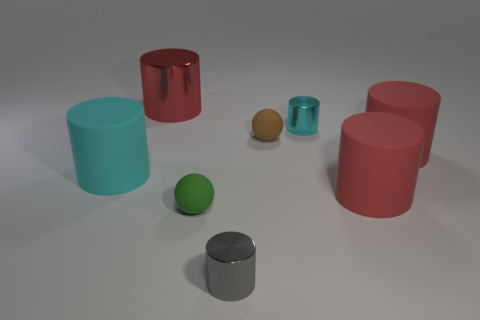Subtract all red cylinders. How many were subtracted if there are2red cylinders left? 1 Subtract all green spheres. How many red cylinders are left? 3 Subtract all cyan cylinders. How many cylinders are left? 4 Subtract 2 cylinders. How many cylinders are left? 4 Subtract all big red metal cylinders. How many cylinders are left? 5 Subtract all green cylinders. Subtract all red blocks. How many cylinders are left? 6 Add 1 brown metallic cylinders. How many objects exist? 9 Subtract all balls. How many objects are left? 6 Subtract all gray matte objects. Subtract all small rubber things. How many objects are left? 6 Add 4 small brown spheres. How many small brown spheres are left? 5 